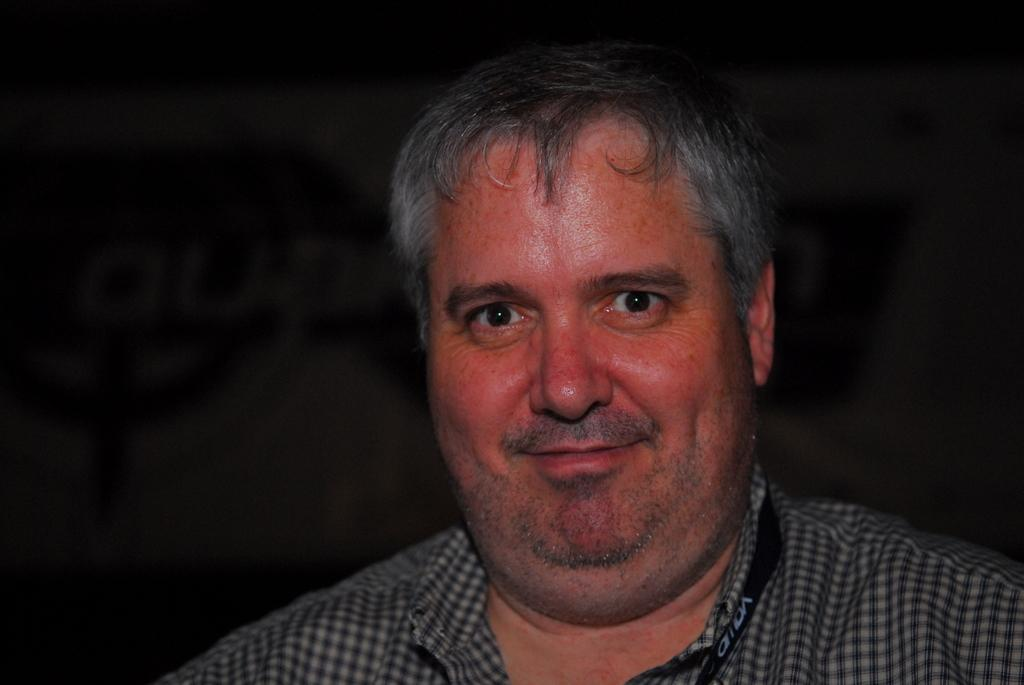What is the main subject of the image? The main subject of the image is a person's face. What is the person wearing in the image? The person is wearing a checked shirt in the image. What other object is visible in the image? There is a black color ID card tag in the image. What type of scale can be seen in the image? There is no scale present in the image. Can you describe the street where the person is standing in the image? The image does not show a street or any indication of the person's location. 